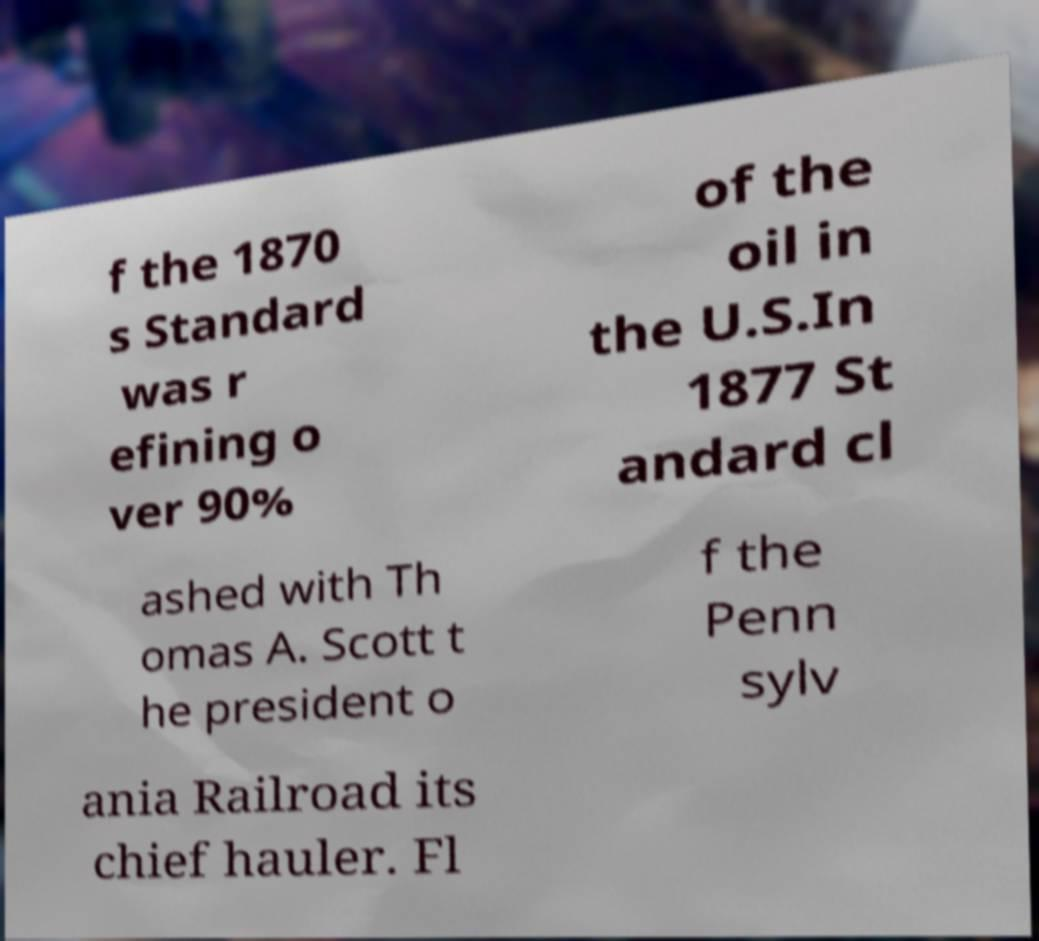I need the written content from this picture converted into text. Can you do that? f the 1870 s Standard was r efining o ver 90% of the oil in the U.S.In 1877 St andard cl ashed with Th omas A. Scott t he president o f the Penn sylv ania Railroad its chief hauler. Fl 